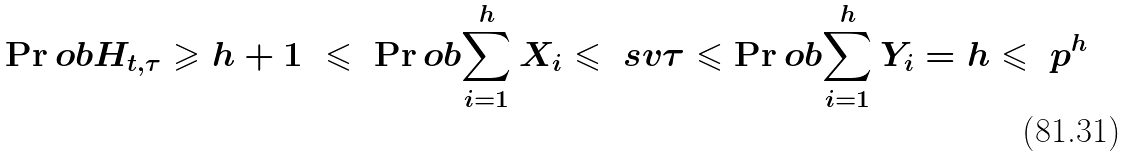Convert formula to latex. <formula><loc_0><loc_0><loc_500><loc_500>\Pr o b { H _ { t , \tau } \geqslant h + 1 } \ \leqslant \ \Pr o b { \sum _ { i = 1 } ^ { h } X _ { i } \leqslant \ s v \tau } \leqslant \Pr o b { \sum _ { i = 1 } ^ { h } Y _ { i } = h } \leqslant \ p ^ { h }</formula> 